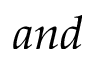<formula> <loc_0><loc_0><loc_500><loc_500>a n d</formula> 